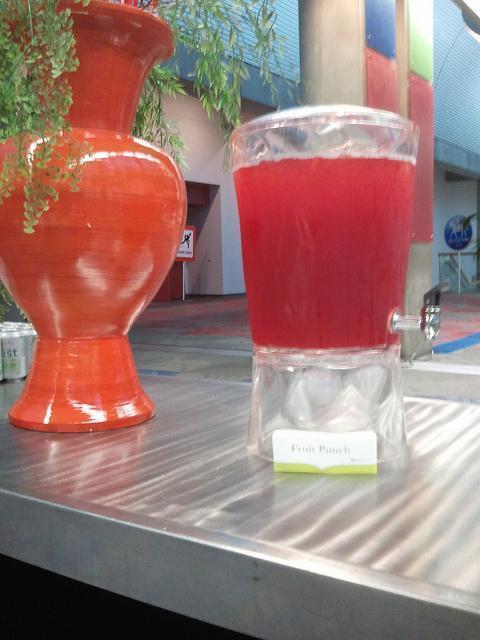What type of station is this?
Make your selection and explain in format: 'Answer: answer
Rationale: rationale.'
Options: Fire, bus, train, beverage. Answer: beverage.
Rationale: It is a place to get drinks. 